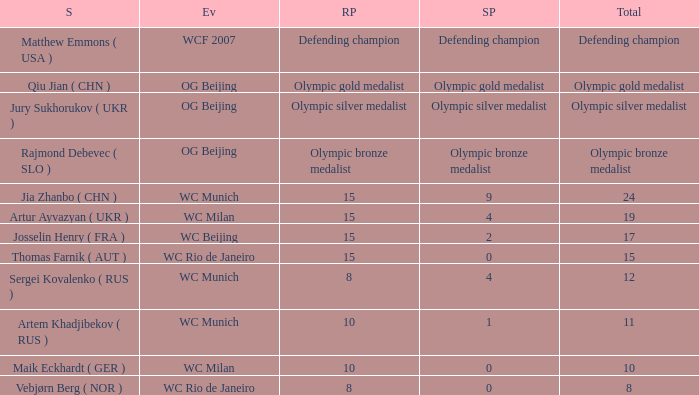With a total of 11, what is the score points? 1.0. 